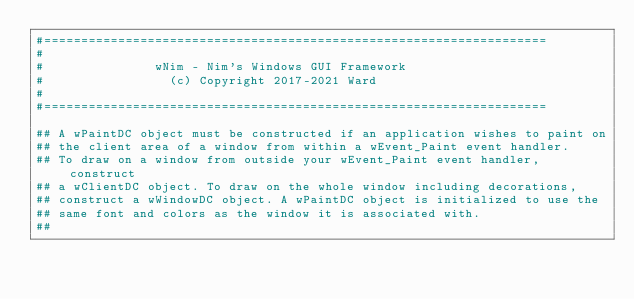Convert code to text. <code><loc_0><loc_0><loc_500><loc_500><_Nim_>#====================================================================
#
#               wNim - Nim's Windows GUI Framework
#                 (c) Copyright 2017-2021 Ward
#
#====================================================================

## A wPaintDC object must be constructed if an application wishes to paint on
## the client area of a window from within a wEvent_Paint event handler.
## To draw on a window from outside your wEvent_Paint event handler, construct
## a wClientDC object. To draw on the whole window including decorations,
## construct a wWindowDC object. A wPaintDC object is initialized to use the
## same font and colors as the window it is associated with.
##</code> 